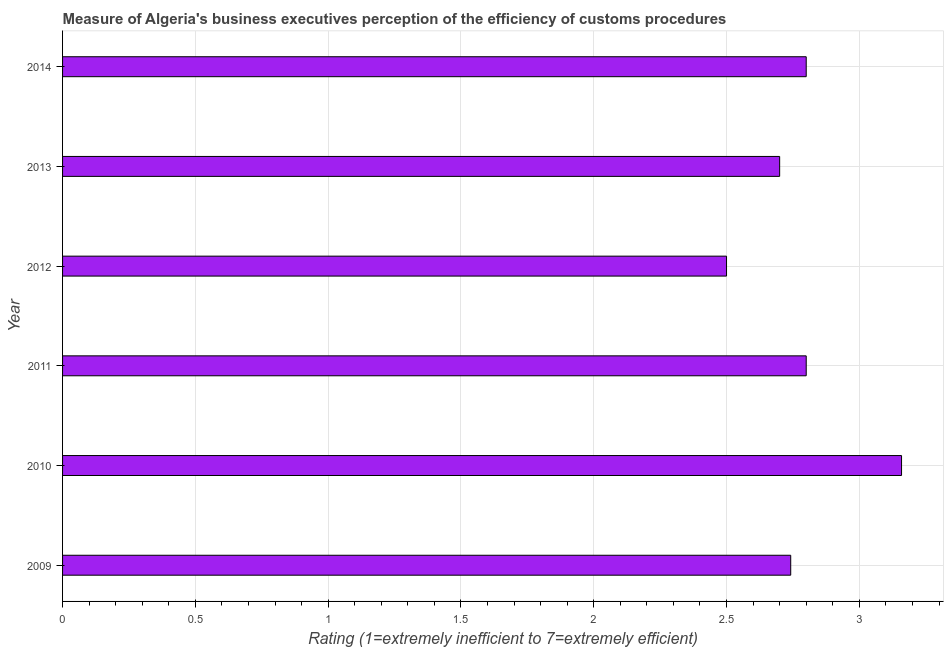Does the graph contain any zero values?
Your answer should be compact. No. What is the title of the graph?
Your response must be concise. Measure of Algeria's business executives perception of the efficiency of customs procedures. What is the label or title of the X-axis?
Your response must be concise. Rating (1=extremely inefficient to 7=extremely efficient). What is the label or title of the Y-axis?
Give a very brief answer. Year. What is the rating measuring burden of customs procedure in 2010?
Offer a very short reply. 3.16. Across all years, what is the maximum rating measuring burden of customs procedure?
Your answer should be very brief. 3.16. Across all years, what is the minimum rating measuring burden of customs procedure?
Give a very brief answer. 2.5. In which year was the rating measuring burden of customs procedure maximum?
Your answer should be very brief. 2010. What is the sum of the rating measuring burden of customs procedure?
Offer a terse response. 16.7. What is the difference between the rating measuring burden of customs procedure in 2013 and 2014?
Ensure brevity in your answer.  -0.1. What is the average rating measuring burden of customs procedure per year?
Give a very brief answer. 2.78. What is the median rating measuring burden of customs procedure?
Keep it short and to the point. 2.77. What is the ratio of the rating measuring burden of customs procedure in 2010 to that in 2013?
Provide a succinct answer. 1.17. Is the rating measuring burden of customs procedure in 2012 less than that in 2014?
Your answer should be compact. Yes. What is the difference between the highest and the second highest rating measuring burden of customs procedure?
Your answer should be compact. 0.36. What is the difference between the highest and the lowest rating measuring burden of customs procedure?
Offer a terse response. 0.66. How many years are there in the graph?
Your answer should be very brief. 6. What is the difference between two consecutive major ticks on the X-axis?
Offer a very short reply. 0.5. What is the Rating (1=extremely inefficient to 7=extremely efficient) of 2009?
Offer a terse response. 2.74. What is the Rating (1=extremely inefficient to 7=extremely efficient) of 2010?
Your response must be concise. 3.16. What is the Rating (1=extremely inefficient to 7=extremely efficient) of 2011?
Provide a succinct answer. 2.8. What is the difference between the Rating (1=extremely inefficient to 7=extremely efficient) in 2009 and 2010?
Your answer should be very brief. -0.42. What is the difference between the Rating (1=extremely inefficient to 7=extremely efficient) in 2009 and 2011?
Ensure brevity in your answer.  -0.06. What is the difference between the Rating (1=extremely inefficient to 7=extremely efficient) in 2009 and 2012?
Keep it short and to the point. 0.24. What is the difference between the Rating (1=extremely inefficient to 7=extremely efficient) in 2009 and 2013?
Ensure brevity in your answer.  0.04. What is the difference between the Rating (1=extremely inefficient to 7=extremely efficient) in 2009 and 2014?
Your answer should be compact. -0.06. What is the difference between the Rating (1=extremely inefficient to 7=extremely efficient) in 2010 and 2011?
Keep it short and to the point. 0.36. What is the difference between the Rating (1=extremely inefficient to 7=extremely efficient) in 2010 and 2012?
Keep it short and to the point. 0.66. What is the difference between the Rating (1=extremely inefficient to 7=extremely efficient) in 2010 and 2013?
Provide a short and direct response. 0.46. What is the difference between the Rating (1=extremely inefficient to 7=extremely efficient) in 2010 and 2014?
Keep it short and to the point. 0.36. What is the difference between the Rating (1=extremely inefficient to 7=extremely efficient) in 2011 and 2012?
Offer a very short reply. 0.3. What is the difference between the Rating (1=extremely inefficient to 7=extremely efficient) in 2011 and 2013?
Offer a terse response. 0.1. What is the difference between the Rating (1=extremely inefficient to 7=extremely efficient) in 2011 and 2014?
Provide a succinct answer. 0. What is the difference between the Rating (1=extremely inefficient to 7=extremely efficient) in 2012 and 2013?
Your answer should be very brief. -0.2. What is the ratio of the Rating (1=extremely inefficient to 7=extremely efficient) in 2009 to that in 2010?
Your answer should be compact. 0.87. What is the ratio of the Rating (1=extremely inefficient to 7=extremely efficient) in 2009 to that in 2012?
Keep it short and to the point. 1.1. What is the ratio of the Rating (1=extremely inefficient to 7=extremely efficient) in 2009 to that in 2013?
Provide a succinct answer. 1.01. What is the ratio of the Rating (1=extremely inefficient to 7=extremely efficient) in 2009 to that in 2014?
Your response must be concise. 0.98. What is the ratio of the Rating (1=extremely inefficient to 7=extremely efficient) in 2010 to that in 2011?
Your answer should be compact. 1.13. What is the ratio of the Rating (1=extremely inefficient to 7=extremely efficient) in 2010 to that in 2012?
Give a very brief answer. 1.26. What is the ratio of the Rating (1=extremely inefficient to 7=extremely efficient) in 2010 to that in 2013?
Your answer should be compact. 1.17. What is the ratio of the Rating (1=extremely inefficient to 7=extremely efficient) in 2010 to that in 2014?
Make the answer very short. 1.13. What is the ratio of the Rating (1=extremely inefficient to 7=extremely efficient) in 2011 to that in 2012?
Offer a terse response. 1.12. What is the ratio of the Rating (1=extremely inefficient to 7=extremely efficient) in 2011 to that in 2014?
Your response must be concise. 1. What is the ratio of the Rating (1=extremely inefficient to 7=extremely efficient) in 2012 to that in 2013?
Your answer should be compact. 0.93. What is the ratio of the Rating (1=extremely inefficient to 7=extremely efficient) in 2012 to that in 2014?
Provide a succinct answer. 0.89. 